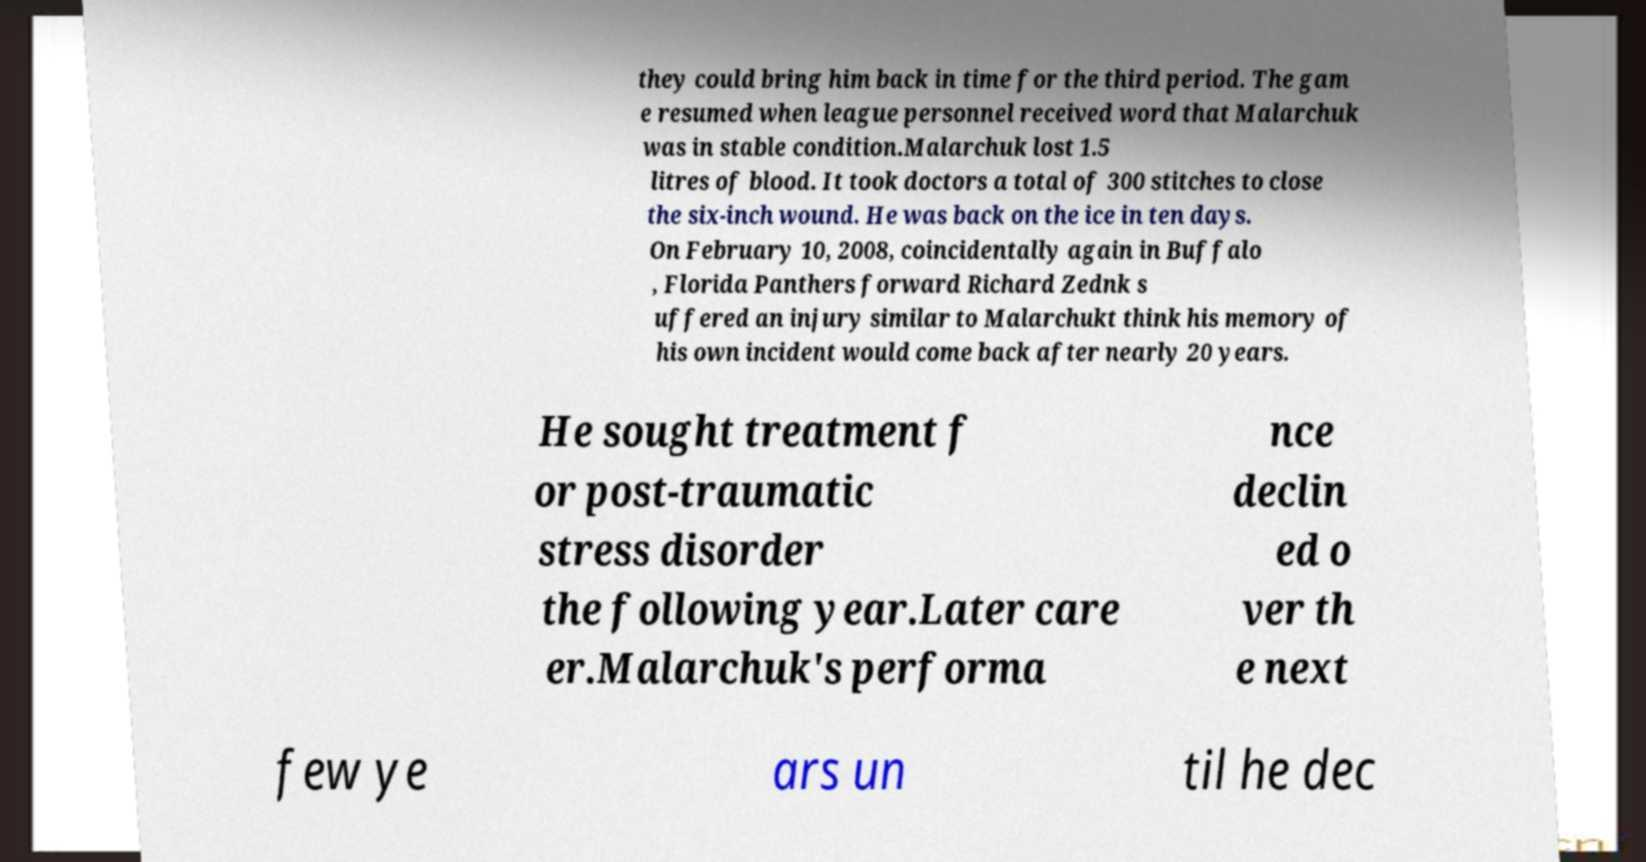Could you assist in decoding the text presented in this image and type it out clearly? they could bring him back in time for the third period. The gam e resumed when league personnel received word that Malarchuk was in stable condition.Malarchuk lost 1.5 litres of blood. It took doctors a total of 300 stitches to close the six-inch wound. He was back on the ice in ten days. On February 10, 2008, coincidentally again in Buffalo , Florida Panthers forward Richard Zednk s uffered an injury similar to Malarchukt think his memory of his own incident would come back after nearly 20 years. He sought treatment f or post-traumatic stress disorder the following year.Later care er.Malarchuk's performa nce declin ed o ver th e next few ye ars un til he dec 